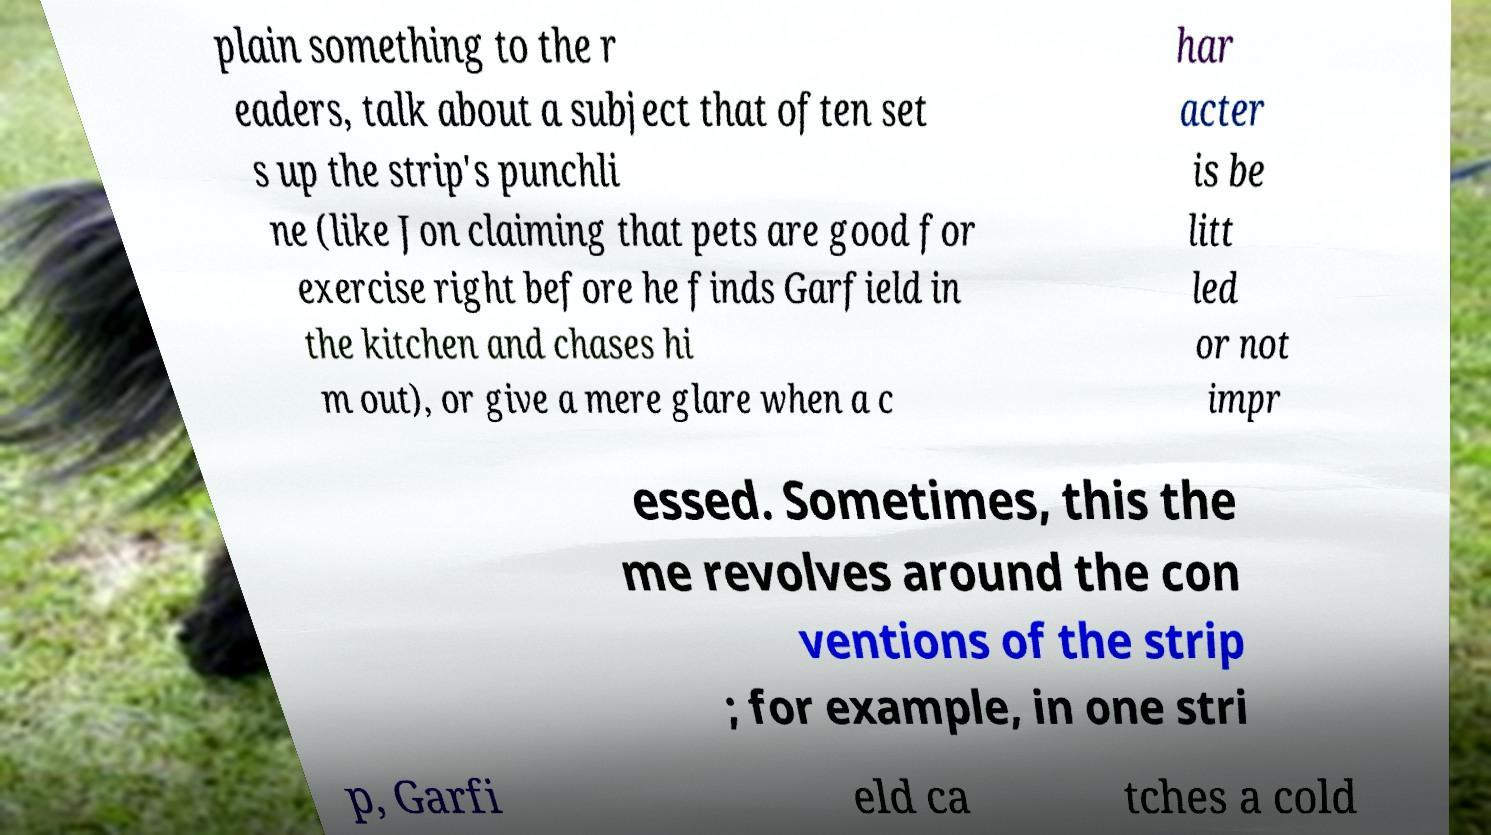Please read and relay the text visible in this image. What does it say? plain something to the r eaders, talk about a subject that often set s up the strip's punchli ne (like Jon claiming that pets are good for exercise right before he finds Garfield in the kitchen and chases hi m out), or give a mere glare when a c har acter is be litt led or not impr essed. Sometimes, this the me revolves around the con ventions of the strip ; for example, in one stri p, Garfi eld ca tches a cold 